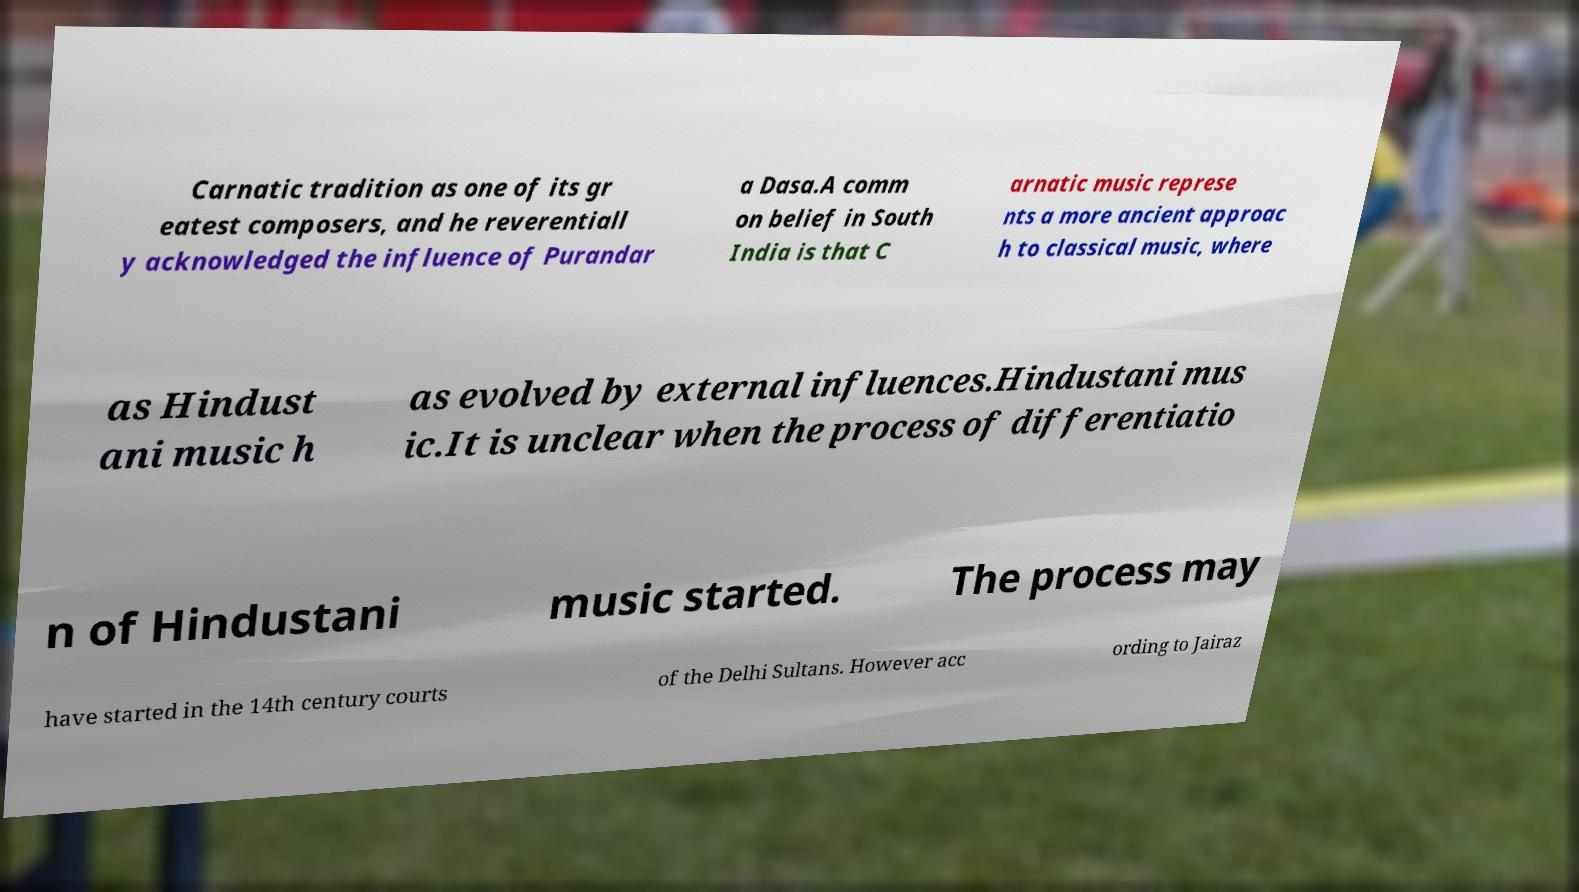Please identify and transcribe the text found in this image. Carnatic tradition as one of its gr eatest composers, and he reverentiall y acknowledged the influence of Purandar a Dasa.A comm on belief in South India is that C arnatic music represe nts a more ancient approac h to classical music, where as Hindust ani music h as evolved by external influences.Hindustani mus ic.It is unclear when the process of differentiatio n of Hindustani music started. The process may have started in the 14th century courts of the Delhi Sultans. However acc ording to Jairaz 